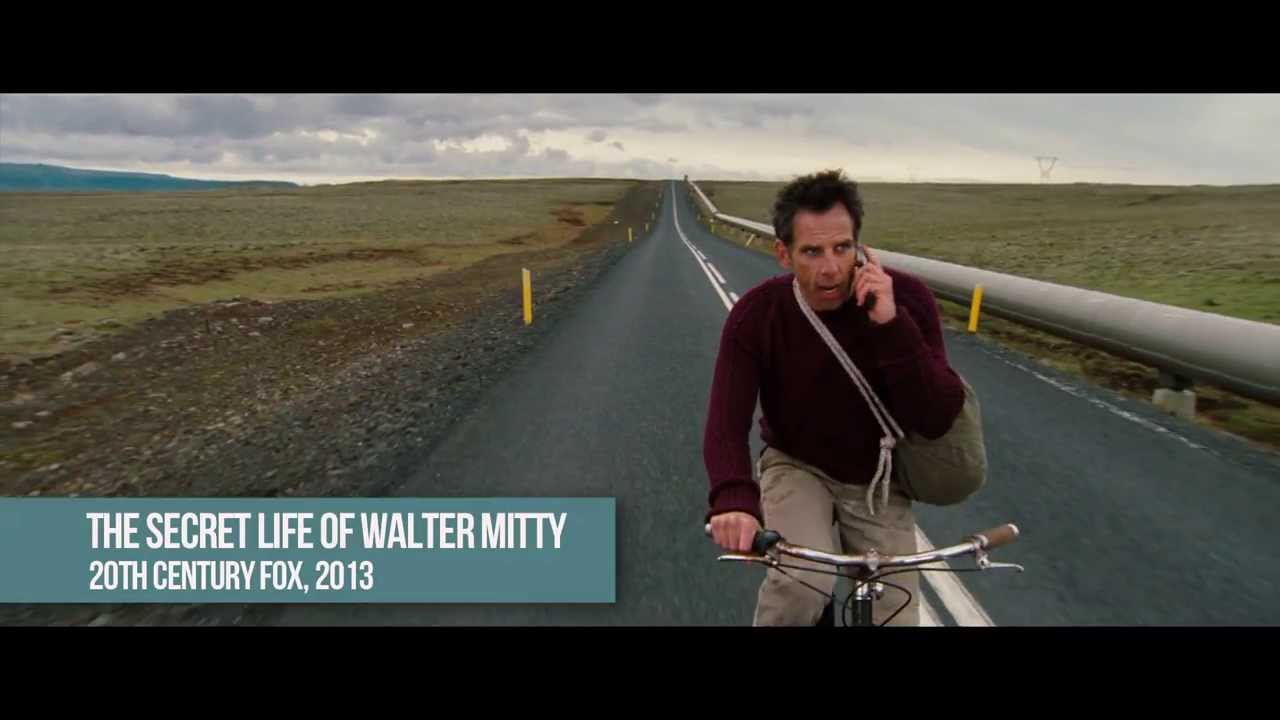If this scene were part of a dream, what would its symbolic elements represent? In a dream context, the long, desolate road could symbolize the journey of life with its challenges, isolation, and uncertainty. The overcast sky represents the cloud of doubt, fear, and anxiety overshadowing one's mind. The bicycle signifies the need for self-effort and perseverance in overcoming obstacles. The man's worried expression and hurried pedaling might symbolize feelings of urgency and the pressure to achieve goals against the clock. The barren landscape reflects a state of emptiness or lack of fulfillment, suggesting a quest for purpose or meaning. The fact that he is alone could indicate a struggle with personal issues or the search for self-discovery. 